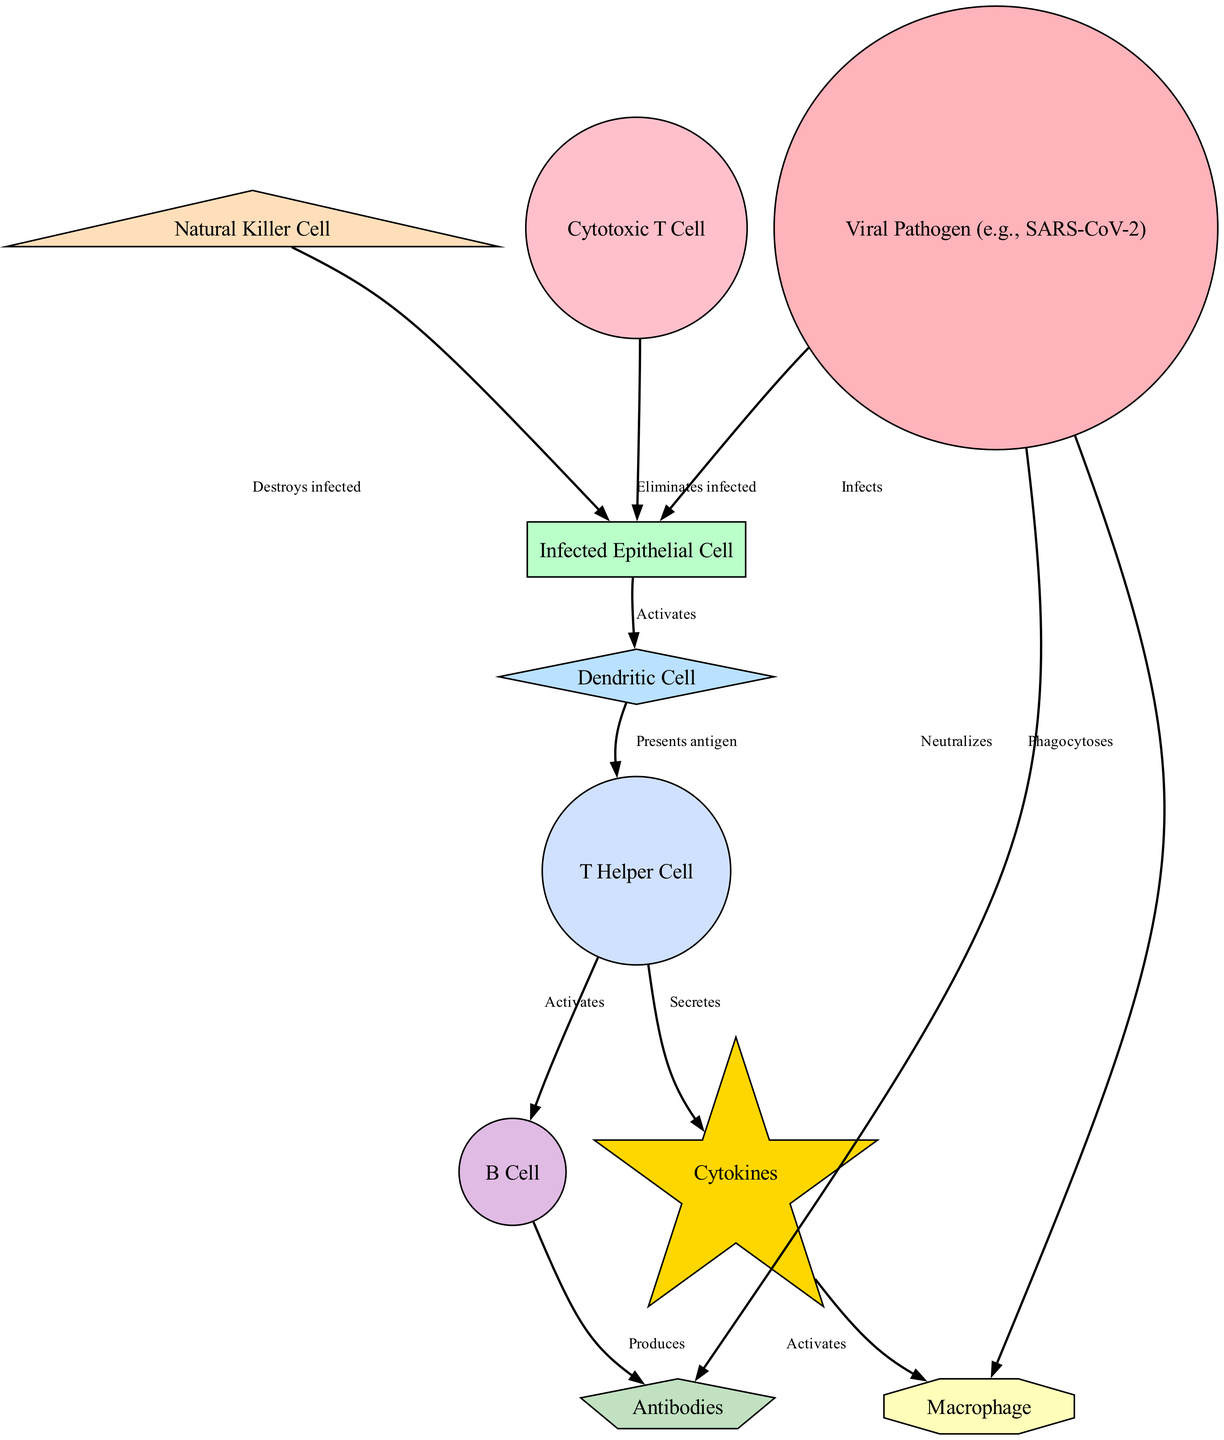What is the first node in the immune response? The first node to be activated in the diagram is the Viral Pathogen since it is the initial element that triggers the immune response by infecting the epithelial cells.
Answer: Viral Pathogen How many key cellular components are involved in the immune response? By counting the nodes in the diagram, we find there are a total of 10 distinct key cellular components involved in the immune response.
Answer: 10 What does the Dendritic Cell do in the immune response? The Dendritic Cell is specifically responsible for presenting antigens to T Helper Cells after it is activated by the infected epithelial cells. This is critical for the subsequent T Cell activation.
Answer: Presents antigen Which cell type directly eliminates infected epithelial cells? The diagram indicates two types of cells that directly eliminate infected epithelial cells: the Natural Killer Cell and the Cytotoxic T Cell. They both actively destroy the infected cells as shown.
Answer: Natural Killer Cell and Cytotoxic T Cell How do Antibodies interact with the Viral Pathogen? According to the diagram, Antibodies neutralize the Viral Pathogen, meaning they bind to the virus and prevent it from causing further infection.
Answer: Neutralizes What role do Cytokines play in the immune response? Cytokines are secreted by T Helper Cells and serve to activate macrophages, which enhance the immune response by promoting inflammation and phagocytosis.
Answer: Activates macrophages Which node is responsible for phagocytosing the virus? The Macrophage is indicated in the diagram to be responsible for phagocytosing the virus, actively engulfing and destroying it during the immune response.
Answer: Macrophage What is the relationship between T Helper Cells and B Cells? The T Helper Cells activate B Cells, which is a critical step in the adaptive immune response as it leads to the production of antibodies for targeting the virus.
Answer: Activates How are the Epithelial Cells activated in the immune response? The Epithelial Cells are activated by dendritic cells as a response to their infection, which is visually represented in the diagram with a directed edge showing this interaction.
Answer: Activates How does the immune response culminate in neutralizing the virus? The immune response culminates in neutralizing the virus through the production of antibodies by B Cells, which are activated by T Helper Cells, and antibodies then bind to and neutralize the virus.
Answer: Neutralizes 